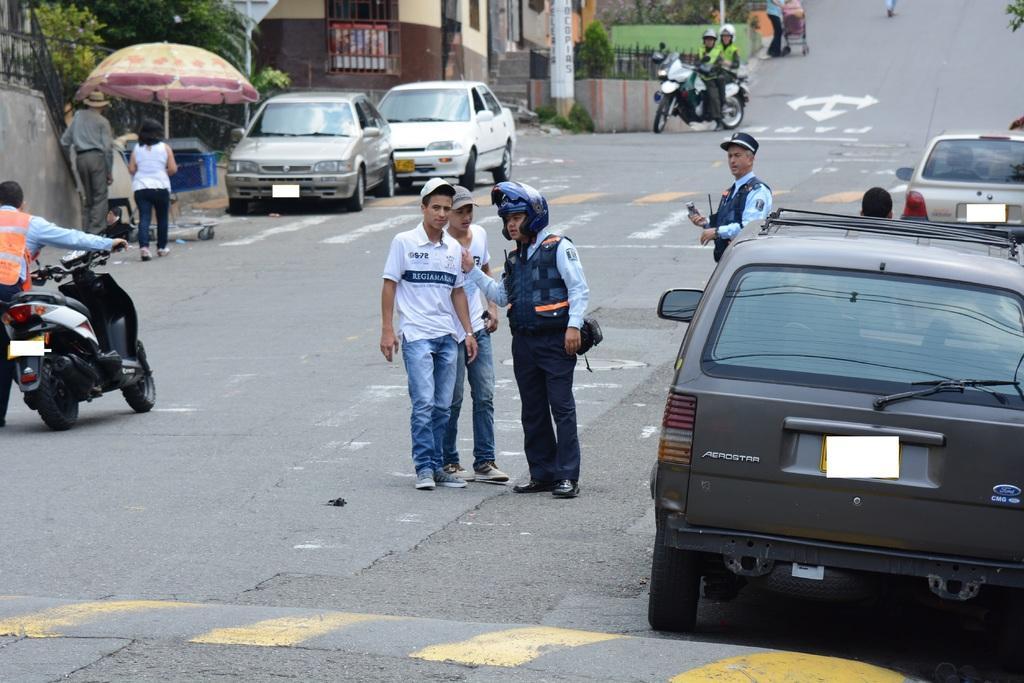In one or two sentences, can you explain what this image depicts? The image is outside of the city. In the image there are group of people standing and walking on left side there are two people sitting on bike, on right side we can see few cars and on left side we can see some cars. In background there is a building,tree at bottom there is a road which is in black color. 